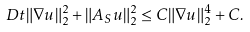<formula> <loc_0><loc_0><loc_500><loc_500>\ D t \| \nabla u \| _ { 2 } ^ { 2 } + \| A _ { S } u \| _ { 2 } ^ { 2 } \leq C \| \nabla u \| _ { 2 } ^ { 4 } + C .</formula> 